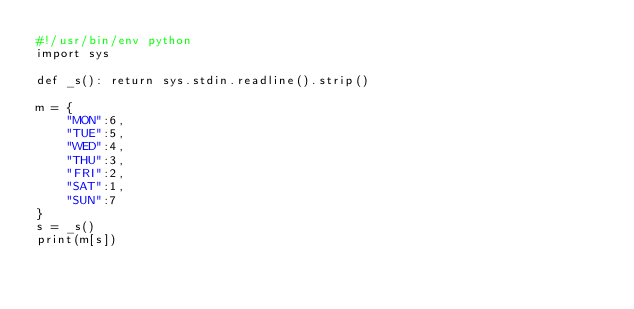<code> <loc_0><loc_0><loc_500><loc_500><_Python_>#!/usr/bin/env python
import sys

def _s(): return sys.stdin.readline().strip()

m = {
    "MON":6,
    "TUE":5,
    "WED":4,
    "THU":3,
    "FRI":2,
    "SAT":1,
    "SUN":7
}
s = _s()
print(m[s])
</code> 